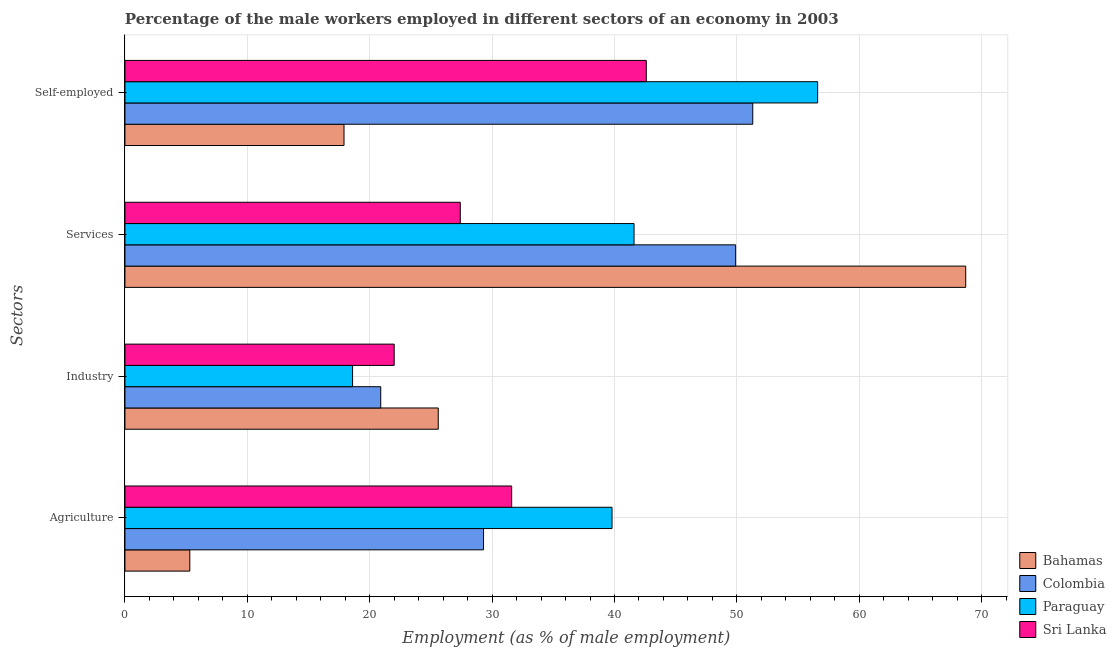How many different coloured bars are there?
Offer a terse response. 4. What is the label of the 3rd group of bars from the top?
Your response must be concise. Industry. What is the percentage of male workers in agriculture in Sri Lanka?
Provide a succinct answer. 31.6. Across all countries, what is the maximum percentage of male workers in industry?
Your answer should be compact. 25.6. Across all countries, what is the minimum percentage of male workers in services?
Your answer should be very brief. 27.4. In which country was the percentage of male workers in industry maximum?
Offer a very short reply. Bahamas. In which country was the percentage of self employed male workers minimum?
Your response must be concise. Bahamas. What is the total percentage of self employed male workers in the graph?
Your answer should be very brief. 168.4. What is the difference between the percentage of self employed male workers in Paraguay and that in Bahamas?
Give a very brief answer. 38.7. What is the difference between the percentage of male workers in industry in Bahamas and the percentage of male workers in services in Paraguay?
Offer a very short reply. -16. What is the average percentage of male workers in services per country?
Offer a terse response. 46.9. What is the difference between the percentage of male workers in agriculture and percentage of male workers in industry in Sri Lanka?
Provide a succinct answer. 9.6. What is the ratio of the percentage of male workers in services in Bahamas to that in Colombia?
Provide a succinct answer. 1.38. What is the difference between the highest and the second highest percentage of male workers in industry?
Ensure brevity in your answer.  3.6. What is the difference between the highest and the lowest percentage of male workers in industry?
Offer a terse response. 7. Is the sum of the percentage of self employed male workers in Sri Lanka and Paraguay greater than the maximum percentage of male workers in industry across all countries?
Offer a terse response. Yes. What does the 1st bar from the top in Agriculture represents?
Give a very brief answer. Sri Lanka. Is it the case that in every country, the sum of the percentage of male workers in agriculture and percentage of male workers in industry is greater than the percentage of male workers in services?
Make the answer very short. No. How many bars are there?
Ensure brevity in your answer.  16. Does the graph contain any zero values?
Ensure brevity in your answer.  No. Does the graph contain grids?
Provide a succinct answer. Yes. Where does the legend appear in the graph?
Your response must be concise. Bottom right. How are the legend labels stacked?
Keep it short and to the point. Vertical. What is the title of the graph?
Your answer should be compact. Percentage of the male workers employed in different sectors of an economy in 2003. Does "Eritrea" appear as one of the legend labels in the graph?
Offer a very short reply. No. What is the label or title of the X-axis?
Ensure brevity in your answer.  Employment (as % of male employment). What is the label or title of the Y-axis?
Provide a succinct answer. Sectors. What is the Employment (as % of male employment) in Bahamas in Agriculture?
Your answer should be very brief. 5.3. What is the Employment (as % of male employment) of Colombia in Agriculture?
Provide a succinct answer. 29.3. What is the Employment (as % of male employment) of Paraguay in Agriculture?
Make the answer very short. 39.8. What is the Employment (as % of male employment) in Sri Lanka in Agriculture?
Ensure brevity in your answer.  31.6. What is the Employment (as % of male employment) of Bahamas in Industry?
Your response must be concise. 25.6. What is the Employment (as % of male employment) of Colombia in Industry?
Provide a succinct answer. 20.9. What is the Employment (as % of male employment) in Paraguay in Industry?
Give a very brief answer. 18.6. What is the Employment (as % of male employment) of Bahamas in Services?
Provide a succinct answer. 68.7. What is the Employment (as % of male employment) in Colombia in Services?
Offer a very short reply. 49.9. What is the Employment (as % of male employment) in Paraguay in Services?
Keep it short and to the point. 41.6. What is the Employment (as % of male employment) in Sri Lanka in Services?
Your answer should be compact. 27.4. What is the Employment (as % of male employment) of Bahamas in Self-employed?
Ensure brevity in your answer.  17.9. What is the Employment (as % of male employment) in Colombia in Self-employed?
Make the answer very short. 51.3. What is the Employment (as % of male employment) in Paraguay in Self-employed?
Provide a succinct answer. 56.6. What is the Employment (as % of male employment) of Sri Lanka in Self-employed?
Provide a succinct answer. 42.6. Across all Sectors, what is the maximum Employment (as % of male employment) of Bahamas?
Give a very brief answer. 68.7. Across all Sectors, what is the maximum Employment (as % of male employment) in Colombia?
Provide a short and direct response. 51.3. Across all Sectors, what is the maximum Employment (as % of male employment) of Paraguay?
Your response must be concise. 56.6. Across all Sectors, what is the maximum Employment (as % of male employment) in Sri Lanka?
Keep it short and to the point. 42.6. Across all Sectors, what is the minimum Employment (as % of male employment) of Bahamas?
Your answer should be very brief. 5.3. Across all Sectors, what is the minimum Employment (as % of male employment) of Colombia?
Make the answer very short. 20.9. Across all Sectors, what is the minimum Employment (as % of male employment) of Paraguay?
Provide a succinct answer. 18.6. What is the total Employment (as % of male employment) of Bahamas in the graph?
Provide a short and direct response. 117.5. What is the total Employment (as % of male employment) of Colombia in the graph?
Ensure brevity in your answer.  151.4. What is the total Employment (as % of male employment) of Paraguay in the graph?
Your response must be concise. 156.6. What is the total Employment (as % of male employment) in Sri Lanka in the graph?
Your response must be concise. 123.6. What is the difference between the Employment (as % of male employment) of Bahamas in Agriculture and that in Industry?
Ensure brevity in your answer.  -20.3. What is the difference between the Employment (as % of male employment) of Paraguay in Agriculture and that in Industry?
Your response must be concise. 21.2. What is the difference between the Employment (as % of male employment) in Bahamas in Agriculture and that in Services?
Offer a very short reply. -63.4. What is the difference between the Employment (as % of male employment) of Colombia in Agriculture and that in Services?
Offer a terse response. -20.6. What is the difference between the Employment (as % of male employment) of Paraguay in Agriculture and that in Services?
Provide a succinct answer. -1.8. What is the difference between the Employment (as % of male employment) in Sri Lanka in Agriculture and that in Services?
Give a very brief answer. 4.2. What is the difference between the Employment (as % of male employment) of Bahamas in Agriculture and that in Self-employed?
Your answer should be very brief. -12.6. What is the difference between the Employment (as % of male employment) of Colombia in Agriculture and that in Self-employed?
Give a very brief answer. -22. What is the difference between the Employment (as % of male employment) in Paraguay in Agriculture and that in Self-employed?
Give a very brief answer. -16.8. What is the difference between the Employment (as % of male employment) in Bahamas in Industry and that in Services?
Your answer should be compact. -43.1. What is the difference between the Employment (as % of male employment) in Paraguay in Industry and that in Services?
Provide a short and direct response. -23. What is the difference between the Employment (as % of male employment) in Colombia in Industry and that in Self-employed?
Provide a succinct answer. -30.4. What is the difference between the Employment (as % of male employment) of Paraguay in Industry and that in Self-employed?
Make the answer very short. -38. What is the difference between the Employment (as % of male employment) of Sri Lanka in Industry and that in Self-employed?
Keep it short and to the point. -20.6. What is the difference between the Employment (as % of male employment) in Bahamas in Services and that in Self-employed?
Provide a short and direct response. 50.8. What is the difference between the Employment (as % of male employment) of Colombia in Services and that in Self-employed?
Your response must be concise. -1.4. What is the difference between the Employment (as % of male employment) in Sri Lanka in Services and that in Self-employed?
Provide a succinct answer. -15.2. What is the difference between the Employment (as % of male employment) of Bahamas in Agriculture and the Employment (as % of male employment) of Colombia in Industry?
Ensure brevity in your answer.  -15.6. What is the difference between the Employment (as % of male employment) in Bahamas in Agriculture and the Employment (as % of male employment) in Paraguay in Industry?
Provide a short and direct response. -13.3. What is the difference between the Employment (as % of male employment) of Bahamas in Agriculture and the Employment (as % of male employment) of Sri Lanka in Industry?
Provide a succinct answer. -16.7. What is the difference between the Employment (as % of male employment) in Colombia in Agriculture and the Employment (as % of male employment) in Paraguay in Industry?
Offer a very short reply. 10.7. What is the difference between the Employment (as % of male employment) of Colombia in Agriculture and the Employment (as % of male employment) of Sri Lanka in Industry?
Your answer should be very brief. 7.3. What is the difference between the Employment (as % of male employment) in Bahamas in Agriculture and the Employment (as % of male employment) in Colombia in Services?
Your answer should be compact. -44.6. What is the difference between the Employment (as % of male employment) of Bahamas in Agriculture and the Employment (as % of male employment) of Paraguay in Services?
Give a very brief answer. -36.3. What is the difference between the Employment (as % of male employment) of Bahamas in Agriculture and the Employment (as % of male employment) of Sri Lanka in Services?
Your answer should be compact. -22.1. What is the difference between the Employment (as % of male employment) in Colombia in Agriculture and the Employment (as % of male employment) in Paraguay in Services?
Provide a succinct answer. -12.3. What is the difference between the Employment (as % of male employment) in Paraguay in Agriculture and the Employment (as % of male employment) in Sri Lanka in Services?
Provide a succinct answer. 12.4. What is the difference between the Employment (as % of male employment) in Bahamas in Agriculture and the Employment (as % of male employment) in Colombia in Self-employed?
Give a very brief answer. -46. What is the difference between the Employment (as % of male employment) of Bahamas in Agriculture and the Employment (as % of male employment) of Paraguay in Self-employed?
Provide a short and direct response. -51.3. What is the difference between the Employment (as % of male employment) in Bahamas in Agriculture and the Employment (as % of male employment) in Sri Lanka in Self-employed?
Your answer should be very brief. -37.3. What is the difference between the Employment (as % of male employment) in Colombia in Agriculture and the Employment (as % of male employment) in Paraguay in Self-employed?
Ensure brevity in your answer.  -27.3. What is the difference between the Employment (as % of male employment) in Colombia in Agriculture and the Employment (as % of male employment) in Sri Lanka in Self-employed?
Make the answer very short. -13.3. What is the difference between the Employment (as % of male employment) of Bahamas in Industry and the Employment (as % of male employment) of Colombia in Services?
Provide a succinct answer. -24.3. What is the difference between the Employment (as % of male employment) in Bahamas in Industry and the Employment (as % of male employment) in Paraguay in Services?
Make the answer very short. -16. What is the difference between the Employment (as % of male employment) in Colombia in Industry and the Employment (as % of male employment) in Paraguay in Services?
Your response must be concise. -20.7. What is the difference between the Employment (as % of male employment) in Bahamas in Industry and the Employment (as % of male employment) in Colombia in Self-employed?
Offer a terse response. -25.7. What is the difference between the Employment (as % of male employment) of Bahamas in Industry and the Employment (as % of male employment) of Paraguay in Self-employed?
Offer a terse response. -31. What is the difference between the Employment (as % of male employment) in Bahamas in Industry and the Employment (as % of male employment) in Sri Lanka in Self-employed?
Provide a short and direct response. -17. What is the difference between the Employment (as % of male employment) of Colombia in Industry and the Employment (as % of male employment) of Paraguay in Self-employed?
Your response must be concise. -35.7. What is the difference between the Employment (as % of male employment) of Colombia in Industry and the Employment (as % of male employment) of Sri Lanka in Self-employed?
Your answer should be compact. -21.7. What is the difference between the Employment (as % of male employment) of Paraguay in Industry and the Employment (as % of male employment) of Sri Lanka in Self-employed?
Keep it short and to the point. -24. What is the difference between the Employment (as % of male employment) in Bahamas in Services and the Employment (as % of male employment) in Paraguay in Self-employed?
Keep it short and to the point. 12.1. What is the difference between the Employment (as % of male employment) of Bahamas in Services and the Employment (as % of male employment) of Sri Lanka in Self-employed?
Your answer should be compact. 26.1. What is the average Employment (as % of male employment) in Bahamas per Sectors?
Ensure brevity in your answer.  29.38. What is the average Employment (as % of male employment) of Colombia per Sectors?
Ensure brevity in your answer.  37.85. What is the average Employment (as % of male employment) of Paraguay per Sectors?
Provide a succinct answer. 39.15. What is the average Employment (as % of male employment) in Sri Lanka per Sectors?
Give a very brief answer. 30.9. What is the difference between the Employment (as % of male employment) of Bahamas and Employment (as % of male employment) of Paraguay in Agriculture?
Provide a short and direct response. -34.5. What is the difference between the Employment (as % of male employment) in Bahamas and Employment (as % of male employment) in Sri Lanka in Agriculture?
Your response must be concise. -26.3. What is the difference between the Employment (as % of male employment) of Colombia and Employment (as % of male employment) of Paraguay in Industry?
Provide a succinct answer. 2.3. What is the difference between the Employment (as % of male employment) in Colombia and Employment (as % of male employment) in Sri Lanka in Industry?
Offer a terse response. -1.1. What is the difference between the Employment (as % of male employment) of Bahamas and Employment (as % of male employment) of Paraguay in Services?
Give a very brief answer. 27.1. What is the difference between the Employment (as % of male employment) of Bahamas and Employment (as % of male employment) of Sri Lanka in Services?
Make the answer very short. 41.3. What is the difference between the Employment (as % of male employment) in Bahamas and Employment (as % of male employment) in Colombia in Self-employed?
Provide a succinct answer. -33.4. What is the difference between the Employment (as % of male employment) of Bahamas and Employment (as % of male employment) of Paraguay in Self-employed?
Offer a very short reply. -38.7. What is the difference between the Employment (as % of male employment) in Bahamas and Employment (as % of male employment) in Sri Lanka in Self-employed?
Offer a terse response. -24.7. What is the difference between the Employment (as % of male employment) in Colombia and Employment (as % of male employment) in Paraguay in Self-employed?
Offer a very short reply. -5.3. What is the difference between the Employment (as % of male employment) in Colombia and Employment (as % of male employment) in Sri Lanka in Self-employed?
Make the answer very short. 8.7. What is the ratio of the Employment (as % of male employment) in Bahamas in Agriculture to that in Industry?
Offer a very short reply. 0.21. What is the ratio of the Employment (as % of male employment) in Colombia in Agriculture to that in Industry?
Provide a short and direct response. 1.4. What is the ratio of the Employment (as % of male employment) of Paraguay in Agriculture to that in Industry?
Make the answer very short. 2.14. What is the ratio of the Employment (as % of male employment) of Sri Lanka in Agriculture to that in Industry?
Your response must be concise. 1.44. What is the ratio of the Employment (as % of male employment) in Bahamas in Agriculture to that in Services?
Offer a terse response. 0.08. What is the ratio of the Employment (as % of male employment) in Colombia in Agriculture to that in Services?
Make the answer very short. 0.59. What is the ratio of the Employment (as % of male employment) in Paraguay in Agriculture to that in Services?
Provide a succinct answer. 0.96. What is the ratio of the Employment (as % of male employment) in Sri Lanka in Agriculture to that in Services?
Offer a terse response. 1.15. What is the ratio of the Employment (as % of male employment) in Bahamas in Agriculture to that in Self-employed?
Provide a short and direct response. 0.3. What is the ratio of the Employment (as % of male employment) in Colombia in Agriculture to that in Self-employed?
Keep it short and to the point. 0.57. What is the ratio of the Employment (as % of male employment) in Paraguay in Agriculture to that in Self-employed?
Provide a succinct answer. 0.7. What is the ratio of the Employment (as % of male employment) in Sri Lanka in Agriculture to that in Self-employed?
Provide a short and direct response. 0.74. What is the ratio of the Employment (as % of male employment) of Bahamas in Industry to that in Services?
Your answer should be compact. 0.37. What is the ratio of the Employment (as % of male employment) in Colombia in Industry to that in Services?
Make the answer very short. 0.42. What is the ratio of the Employment (as % of male employment) of Paraguay in Industry to that in Services?
Your answer should be compact. 0.45. What is the ratio of the Employment (as % of male employment) in Sri Lanka in Industry to that in Services?
Your response must be concise. 0.8. What is the ratio of the Employment (as % of male employment) of Bahamas in Industry to that in Self-employed?
Keep it short and to the point. 1.43. What is the ratio of the Employment (as % of male employment) in Colombia in Industry to that in Self-employed?
Ensure brevity in your answer.  0.41. What is the ratio of the Employment (as % of male employment) in Paraguay in Industry to that in Self-employed?
Offer a very short reply. 0.33. What is the ratio of the Employment (as % of male employment) of Sri Lanka in Industry to that in Self-employed?
Make the answer very short. 0.52. What is the ratio of the Employment (as % of male employment) in Bahamas in Services to that in Self-employed?
Offer a very short reply. 3.84. What is the ratio of the Employment (as % of male employment) of Colombia in Services to that in Self-employed?
Give a very brief answer. 0.97. What is the ratio of the Employment (as % of male employment) of Paraguay in Services to that in Self-employed?
Give a very brief answer. 0.73. What is the ratio of the Employment (as % of male employment) of Sri Lanka in Services to that in Self-employed?
Your answer should be compact. 0.64. What is the difference between the highest and the second highest Employment (as % of male employment) in Bahamas?
Provide a succinct answer. 43.1. What is the difference between the highest and the second highest Employment (as % of male employment) of Colombia?
Your answer should be compact. 1.4. What is the difference between the highest and the second highest Employment (as % of male employment) of Paraguay?
Provide a short and direct response. 15. What is the difference between the highest and the lowest Employment (as % of male employment) in Bahamas?
Offer a very short reply. 63.4. What is the difference between the highest and the lowest Employment (as % of male employment) in Colombia?
Your answer should be compact. 30.4. What is the difference between the highest and the lowest Employment (as % of male employment) in Sri Lanka?
Ensure brevity in your answer.  20.6. 